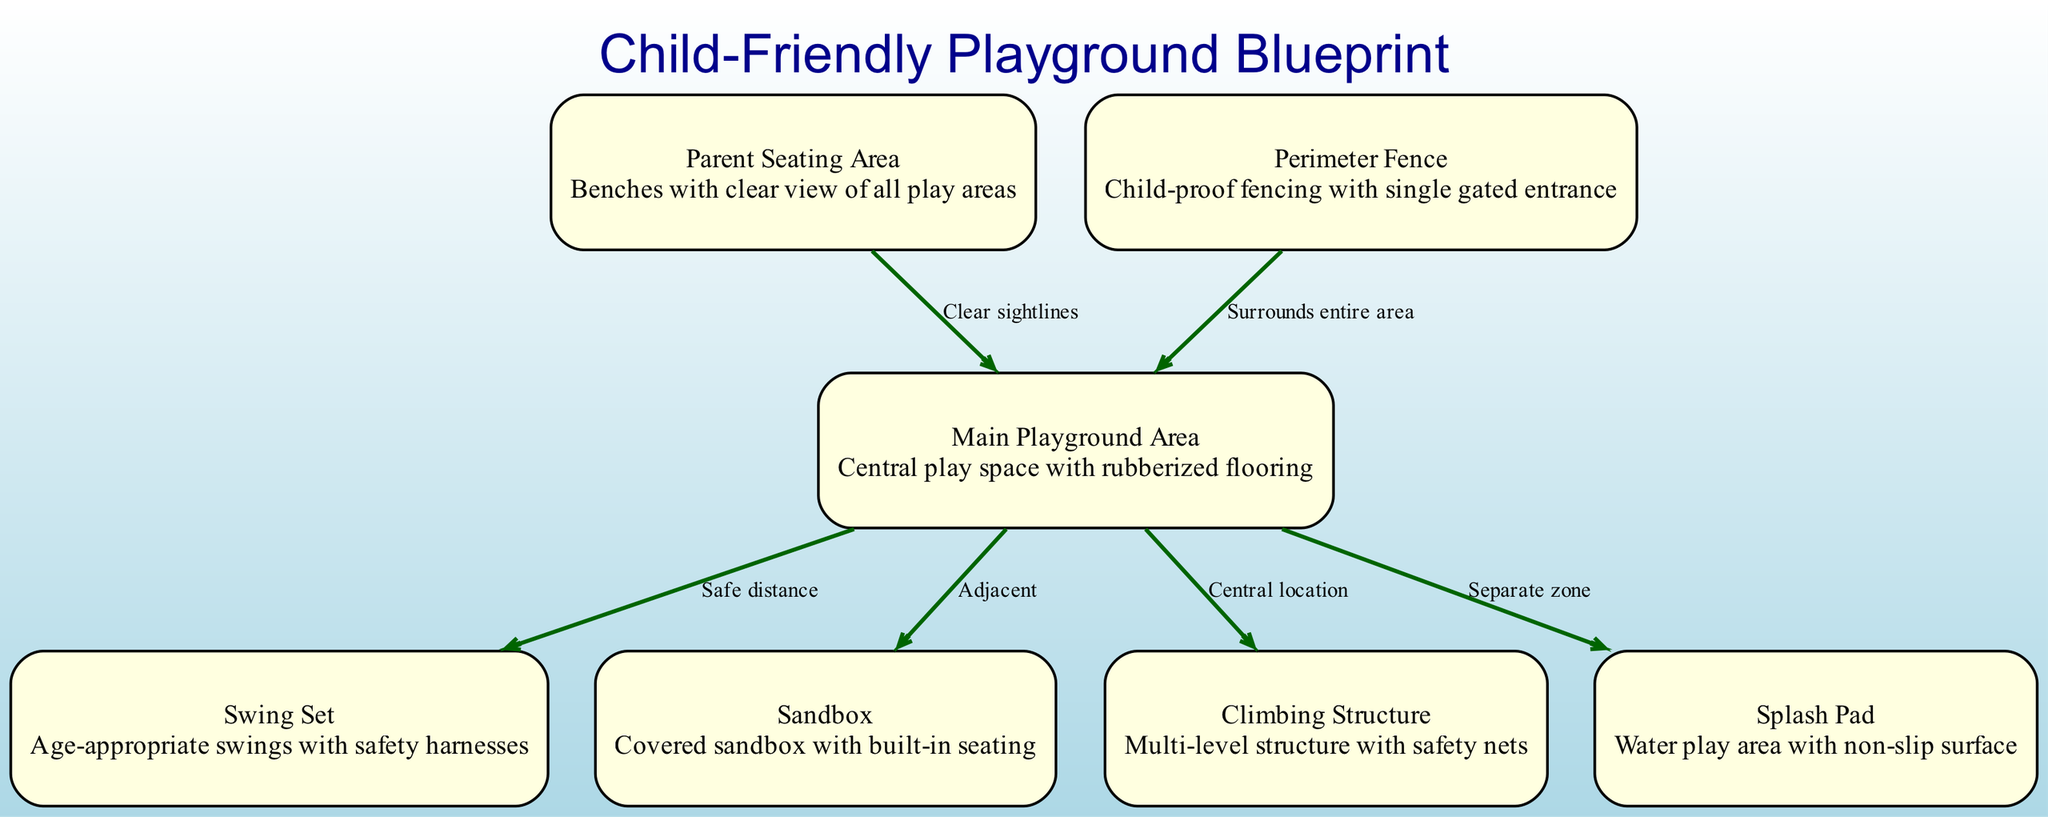What are the two types of play areas in the diagram? The diagram features a sandbox and a splash pad, identified as separate play areas. Both are described individually in the nodes with their characteristics.
Answer: sandbox and splash pad How many safety features are included in the playground design? The diagram includes several safety features: safety harnesses for swings, safety nets for climbing, non-slip surface for the splash pad, and a child-proof perimeter fence. Counting these, we have four distinct safety features.
Answer: four What is the characteristic of the seating area next to the playground? The seating area is designed for parents and is specifically noted for having clear sightlines to all play areas, allowing parents to supervise their children easily.
Answer: clear sightlines What connects the climbing structure and the main playground area? The climbing structure is centrally located in relation to the main playground area, indicating it is positioned in the middle for easy access from all sides.
Answer: central location What is the distance between the swing set and the main playground area? The diagram indicates a safe distance between the swing set and the main playground area, ensuring there is adequate space to prevent accidents during play.
Answer: safe distance What feature surrounds the entire playground area? The playground is surrounded by a perimeter fence, which serves as a safety barrier, particularly important for keeping children secure within the play area.
Answer: perimeter fence How are the sandbox and playground area positioned in relation to each other? The sandbox is described as adjacent to the main playground area, meaning they are placed side by side or very close together for easy access.
Answer: adjacent What is the purpose of the splash pad in the design? The splash pad is categorized as a separate zone and is specifically a water play area, designed for active play, while ensuring safety with a non-slip surface.
Answer: water play area 